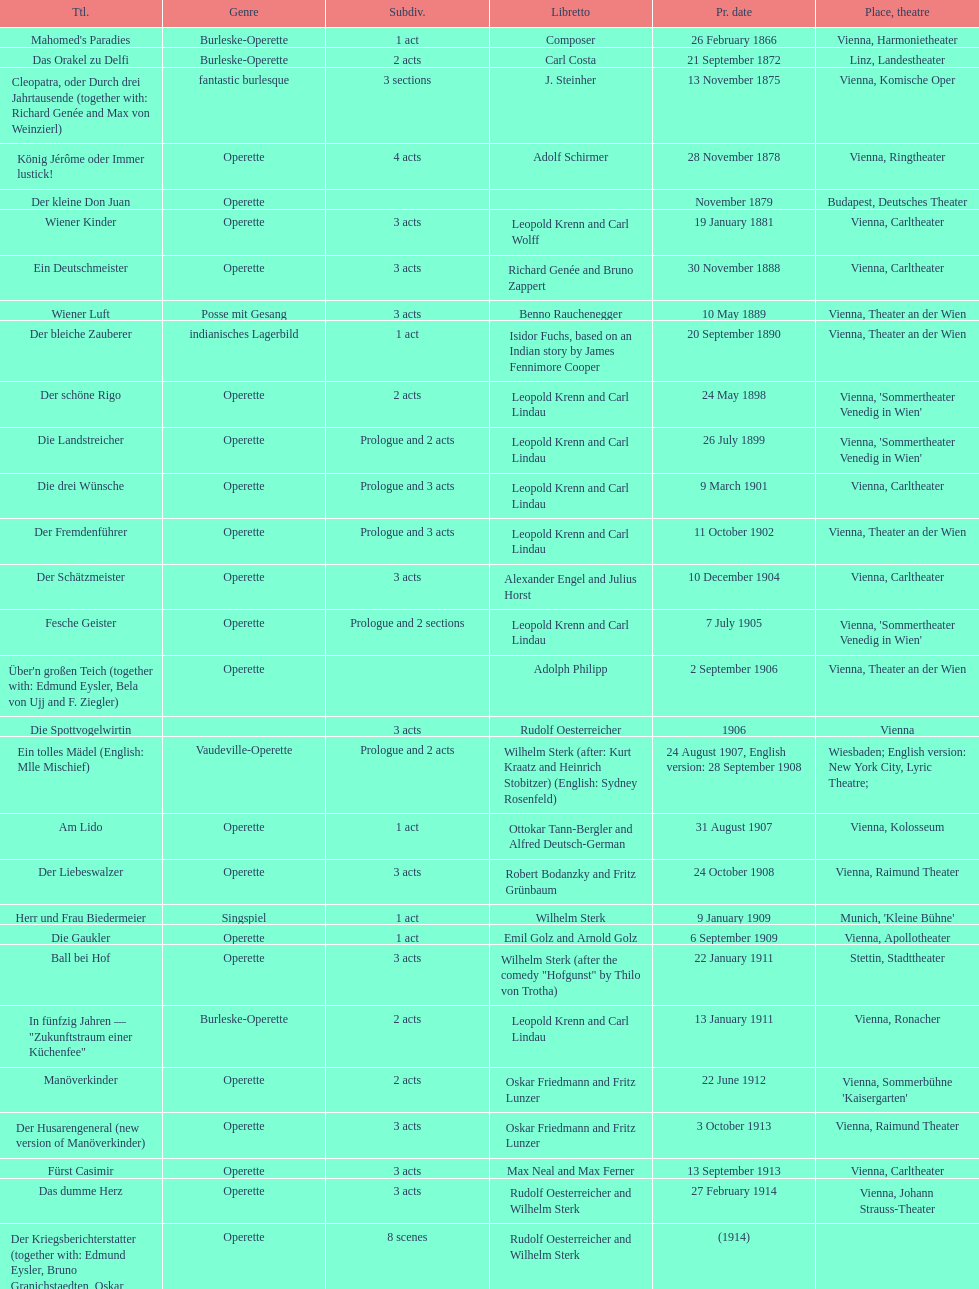How many number of 1 acts were there? 5. 